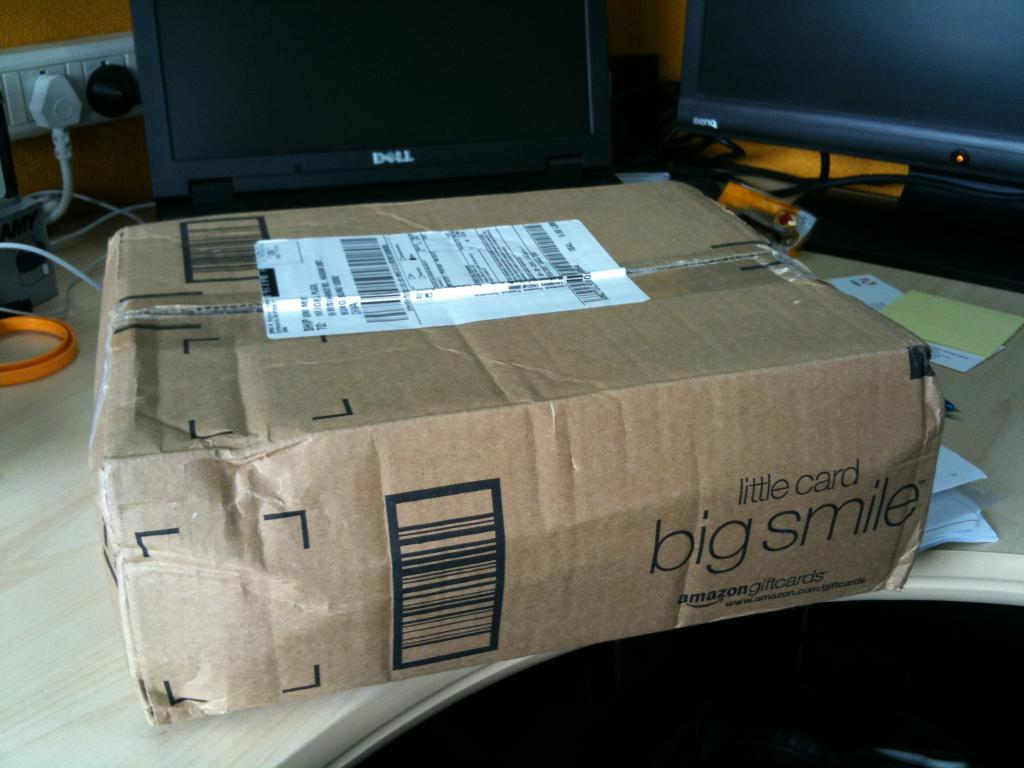<image>
Present a compact description of the photo's key features. A brown package that says little card big smile on the side sitting on a table with a computer behind it. 